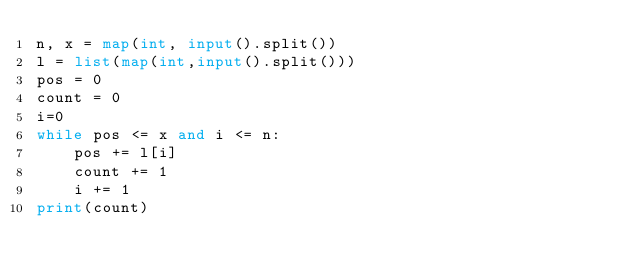<code> <loc_0><loc_0><loc_500><loc_500><_Python_>n, x = map(int, input().split())
l = list(map(int,input().split()))
pos = 0
count = 0
i=0
while pos <= x and i <= n:
    pos += l[i]
    count += 1
    i += 1
print(count)</code> 